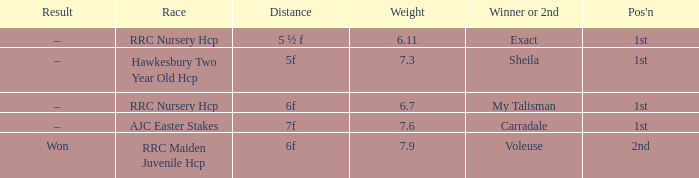What is the title of the champion or runner-up with a weight exceeding Carradale. 